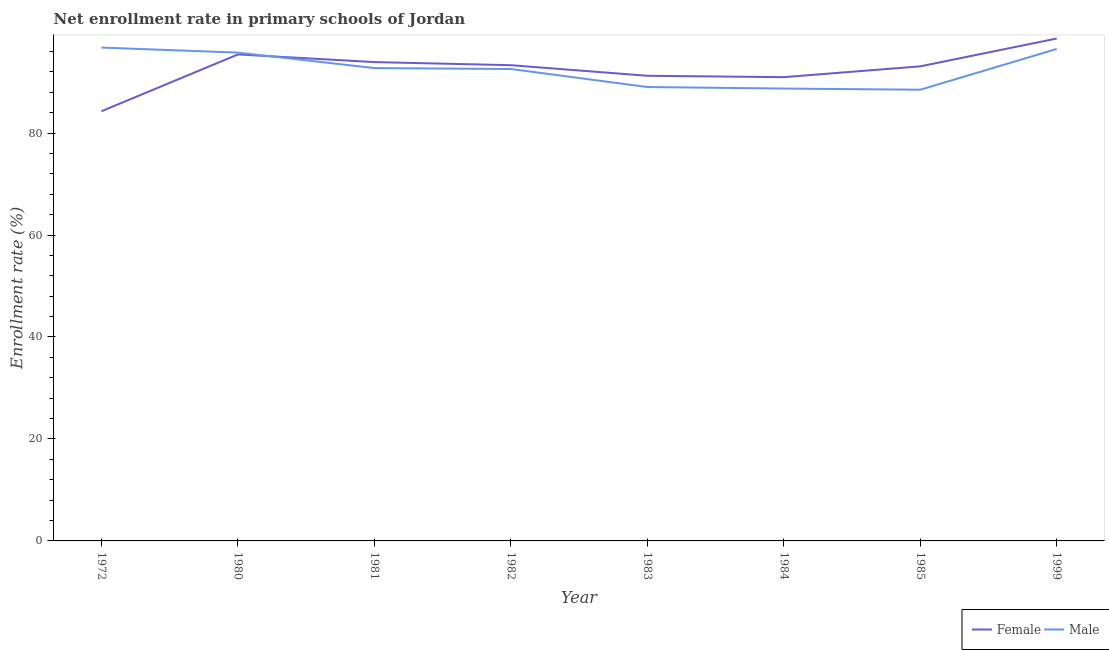How many different coloured lines are there?
Provide a succinct answer. 2. What is the enrollment rate of female students in 1980?
Offer a very short reply. 95.42. Across all years, what is the maximum enrollment rate of male students?
Offer a terse response. 96.76. Across all years, what is the minimum enrollment rate of male students?
Give a very brief answer. 88.5. What is the total enrollment rate of male students in the graph?
Give a very brief answer. 740.58. What is the difference between the enrollment rate of male students in 1972 and that in 1981?
Your answer should be very brief. 4.02. What is the difference between the enrollment rate of male students in 1982 and the enrollment rate of female students in 1983?
Your answer should be compact. 1.33. What is the average enrollment rate of female students per year?
Make the answer very short. 92.59. In the year 1982, what is the difference between the enrollment rate of female students and enrollment rate of male students?
Keep it short and to the point. 0.75. What is the ratio of the enrollment rate of female students in 1982 to that in 1985?
Keep it short and to the point. 1. Is the enrollment rate of male students in 1981 less than that in 1984?
Give a very brief answer. No. What is the difference between the highest and the second highest enrollment rate of female students?
Your answer should be compact. 3.12. What is the difference between the highest and the lowest enrollment rate of female students?
Provide a succinct answer. 14.26. Is the sum of the enrollment rate of female students in 1982 and 1984 greater than the maximum enrollment rate of male students across all years?
Provide a short and direct response. Yes. Does the enrollment rate of female students monotonically increase over the years?
Provide a short and direct response. No. Is the enrollment rate of female students strictly greater than the enrollment rate of male students over the years?
Give a very brief answer. No. How many legend labels are there?
Ensure brevity in your answer.  2. How are the legend labels stacked?
Ensure brevity in your answer.  Horizontal. What is the title of the graph?
Give a very brief answer. Net enrollment rate in primary schools of Jordan. What is the label or title of the Y-axis?
Provide a succinct answer. Enrollment rate (%). What is the Enrollment rate (%) in Female in 1972?
Provide a short and direct response. 84.28. What is the Enrollment rate (%) of Male in 1972?
Keep it short and to the point. 96.76. What is the Enrollment rate (%) of Female in 1980?
Offer a terse response. 95.42. What is the Enrollment rate (%) of Male in 1980?
Your response must be concise. 95.77. What is the Enrollment rate (%) in Female in 1981?
Your answer should be very brief. 93.92. What is the Enrollment rate (%) in Male in 1981?
Make the answer very short. 92.74. What is the Enrollment rate (%) in Female in 1982?
Your answer should be very brief. 93.31. What is the Enrollment rate (%) of Male in 1982?
Your answer should be very brief. 92.56. What is the Enrollment rate (%) of Female in 1983?
Provide a succinct answer. 91.23. What is the Enrollment rate (%) of Male in 1983?
Provide a succinct answer. 89.03. What is the Enrollment rate (%) of Female in 1984?
Provide a short and direct response. 90.96. What is the Enrollment rate (%) of Male in 1984?
Make the answer very short. 88.72. What is the Enrollment rate (%) in Female in 1985?
Your answer should be very brief. 93.08. What is the Enrollment rate (%) in Male in 1985?
Offer a very short reply. 88.5. What is the Enrollment rate (%) of Female in 1999?
Provide a succinct answer. 98.54. What is the Enrollment rate (%) in Male in 1999?
Provide a short and direct response. 96.49. Across all years, what is the maximum Enrollment rate (%) in Female?
Offer a terse response. 98.54. Across all years, what is the maximum Enrollment rate (%) of Male?
Offer a very short reply. 96.76. Across all years, what is the minimum Enrollment rate (%) in Female?
Make the answer very short. 84.28. Across all years, what is the minimum Enrollment rate (%) of Male?
Offer a terse response. 88.5. What is the total Enrollment rate (%) of Female in the graph?
Give a very brief answer. 740.74. What is the total Enrollment rate (%) of Male in the graph?
Your answer should be very brief. 740.58. What is the difference between the Enrollment rate (%) of Female in 1972 and that in 1980?
Your response must be concise. -11.14. What is the difference between the Enrollment rate (%) of Male in 1972 and that in 1980?
Provide a succinct answer. 0.99. What is the difference between the Enrollment rate (%) in Female in 1972 and that in 1981?
Ensure brevity in your answer.  -9.64. What is the difference between the Enrollment rate (%) in Male in 1972 and that in 1981?
Make the answer very short. 4.02. What is the difference between the Enrollment rate (%) in Female in 1972 and that in 1982?
Provide a short and direct response. -9.03. What is the difference between the Enrollment rate (%) in Male in 1972 and that in 1982?
Ensure brevity in your answer.  4.2. What is the difference between the Enrollment rate (%) in Female in 1972 and that in 1983?
Offer a very short reply. -6.95. What is the difference between the Enrollment rate (%) of Male in 1972 and that in 1983?
Your response must be concise. 7.74. What is the difference between the Enrollment rate (%) of Female in 1972 and that in 1984?
Your response must be concise. -6.68. What is the difference between the Enrollment rate (%) of Male in 1972 and that in 1984?
Keep it short and to the point. 8.04. What is the difference between the Enrollment rate (%) of Female in 1972 and that in 1985?
Provide a succinct answer. -8.8. What is the difference between the Enrollment rate (%) in Male in 1972 and that in 1985?
Your response must be concise. 8.27. What is the difference between the Enrollment rate (%) of Female in 1972 and that in 1999?
Provide a short and direct response. -14.26. What is the difference between the Enrollment rate (%) in Male in 1972 and that in 1999?
Give a very brief answer. 0.27. What is the difference between the Enrollment rate (%) in Female in 1980 and that in 1981?
Provide a succinct answer. 1.5. What is the difference between the Enrollment rate (%) in Male in 1980 and that in 1981?
Provide a short and direct response. 3.03. What is the difference between the Enrollment rate (%) of Female in 1980 and that in 1982?
Make the answer very short. 2.11. What is the difference between the Enrollment rate (%) of Male in 1980 and that in 1982?
Your answer should be very brief. 3.22. What is the difference between the Enrollment rate (%) of Female in 1980 and that in 1983?
Keep it short and to the point. 4.19. What is the difference between the Enrollment rate (%) in Male in 1980 and that in 1983?
Ensure brevity in your answer.  6.75. What is the difference between the Enrollment rate (%) in Female in 1980 and that in 1984?
Keep it short and to the point. 4.46. What is the difference between the Enrollment rate (%) in Male in 1980 and that in 1984?
Offer a terse response. 7.05. What is the difference between the Enrollment rate (%) of Female in 1980 and that in 1985?
Offer a very short reply. 2.34. What is the difference between the Enrollment rate (%) in Male in 1980 and that in 1985?
Your answer should be very brief. 7.28. What is the difference between the Enrollment rate (%) of Female in 1980 and that in 1999?
Offer a terse response. -3.12. What is the difference between the Enrollment rate (%) in Male in 1980 and that in 1999?
Make the answer very short. -0.72. What is the difference between the Enrollment rate (%) in Female in 1981 and that in 1982?
Give a very brief answer. 0.61. What is the difference between the Enrollment rate (%) in Male in 1981 and that in 1982?
Ensure brevity in your answer.  0.18. What is the difference between the Enrollment rate (%) of Female in 1981 and that in 1983?
Ensure brevity in your answer.  2.69. What is the difference between the Enrollment rate (%) in Male in 1981 and that in 1983?
Make the answer very short. 3.72. What is the difference between the Enrollment rate (%) of Female in 1981 and that in 1984?
Give a very brief answer. 2.95. What is the difference between the Enrollment rate (%) in Male in 1981 and that in 1984?
Your response must be concise. 4.02. What is the difference between the Enrollment rate (%) in Female in 1981 and that in 1985?
Your answer should be compact. 0.83. What is the difference between the Enrollment rate (%) in Male in 1981 and that in 1985?
Your answer should be compact. 4.25. What is the difference between the Enrollment rate (%) of Female in 1981 and that in 1999?
Provide a short and direct response. -4.63. What is the difference between the Enrollment rate (%) of Male in 1981 and that in 1999?
Your answer should be very brief. -3.75. What is the difference between the Enrollment rate (%) of Female in 1982 and that in 1983?
Your answer should be very brief. 2.08. What is the difference between the Enrollment rate (%) of Male in 1982 and that in 1983?
Your response must be concise. 3.53. What is the difference between the Enrollment rate (%) of Female in 1982 and that in 1984?
Offer a very short reply. 2.35. What is the difference between the Enrollment rate (%) of Male in 1982 and that in 1984?
Keep it short and to the point. 3.83. What is the difference between the Enrollment rate (%) of Female in 1982 and that in 1985?
Offer a very short reply. 0.23. What is the difference between the Enrollment rate (%) in Male in 1982 and that in 1985?
Your response must be concise. 4.06. What is the difference between the Enrollment rate (%) in Female in 1982 and that in 1999?
Ensure brevity in your answer.  -5.23. What is the difference between the Enrollment rate (%) in Male in 1982 and that in 1999?
Provide a short and direct response. -3.94. What is the difference between the Enrollment rate (%) of Female in 1983 and that in 1984?
Provide a succinct answer. 0.27. What is the difference between the Enrollment rate (%) in Male in 1983 and that in 1984?
Your answer should be compact. 0.3. What is the difference between the Enrollment rate (%) of Female in 1983 and that in 1985?
Your answer should be very brief. -1.85. What is the difference between the Enrollment rate (%) of Male in 1983 and that in 1985?
Ensure brevity in your answer.  0.53. What is the difference between the Enrollment rate (%) of Female in 1983 and that in 1999?
Ensure brevity in your answer.  -7.31. What is the difference between the Enrollment rate (%) in Male in 1983 and that in 1999?
Provide a short and direct response. -7.47. What is the difference between the Enrollment rate (%) in Female in 1984 and that in 1985?
Provide a short and direct response. -2.12. What is the difference between the Enrollment rate (%) in Male in 1984 and that in 1985?
Offer a terse response. 0.23. What is the difference between the Enrollment rate (%) of Female in 1984 and that in 1999?
Offer a very short reply. -7.58. What is the difference between the Enrollment rate (%) in Male in 1984 and that in 1999?
Offer a very short reply. -7.77. What is the difference between the Enrollment rate (%) of Female in 1985 and that in 1999?
Your answer should be compact. -5.46. What is the difference between the Enrollment rate (%) in Male in 1985 and that in 1999?
Provide a succinct answer. -8. What is the difference between the Enrollment rate (%) of Female in 1972 and the Enrollment rate (%) of Male in 1980?
Your answer should be compact. -11.5. What is the difference between the Enrollment rate (%) of Female in 1972 and the Enrollment rate (%) of Male in 1981?
Give a very brief answer. -8.46. What is the difference between the Enrollment rate (%) in Female in 1972 and the Enrollment rate (%) in Male in 1982?
Provide a succinct answer. -8.28. What is the difference between the Enrollment rate (%) in Female in 1972 and the Enrollment rate (%) in Male in 1983?
Ensure brevity in your answer.  -4.75. What is the difference between the Enrollment rate (%) in Female in 1972 and the Enrollment rate (%) in Male in 1984?
Make the answer very short. -4.45. What is the difference between the Enrollment rate (%) in Female in 1972 and the Enrollment rate (%) in Male in 1985?
Provide a short and direct response. -4.22. What is the difference between the Enrollment rate (%) of Female in 1972 and the Enrollment rate (%) of Male in 1999?
Your answer should be very brief. -12.22. What is the difference between the Enrollment rate (%) in Female in 1980 and the Enrollment rate (%) in Male in 1981?
Your answer should be very brief. 2.68. What is the difference between the Enrollment rate (%) of Female in 1980 and the Enrollment rate (%) of Male in 1982?
Your answer should be compact. 2.86. What is the difference between the Enrollment rate (%) in Female in 1980 and the Enrollment rate (%) in Male in 1983?
Your response must be concise. 6.39. What is the difference between the Enrollment rate (%) in Female in 1980 and the Enrollment rate (%) in Male in 1984?
Your response must be concise. 6.69. What is the difference between the Enrollment rate (%) in Female in 1980 and the Enrollment rate (%) in Male in 1985?
Make the answer very short. 6.92. What is the difference between the Enrollment rate (%) of Female in 1980 and the Enrollment rate (%) of Male in 1999?
Make the answer very short. -1.08. What is the difference between the Enrollment rate (%) in Female in 1981 and the Enrollment rate (%) in Male in 1982?
Ensure brevity in your answer.  1.36. What is the difference between the Enrollment rate (%) of Female in 1981 and the Enrollment rate (%) of Male in 1983?
Your answer should be very brief. 4.89. What is the difference between the Enrollment rate (%) of Female in 1981 and the Enrollment rate (%) of Male in 1984?
Make the answer very short. 5.19. What is the difference between the Enrollment rate (%) in Female in 1981 and the Enrollment rate (%) in Male in 1985?
Offer a very short reply. 5.42. What is the difference between the Enrollment rate (%) in Female in 1981 and the Enrollment rate (%) in Male in 1999?
Your response must be concise. -2.58. What is the difference between the Enrollment rate (%) in Female in 1982 and the Enrollment rate (%) in Male in 1983?
Provide a succinct answer. 4.28. What is the difference between the Enrollment rate (%) of Female in 1982 and the Enrollment rate (%) of Male in 1984?
Make the answer very short. 4.58. What is the difference between the Enrollment rate (%) in Female in 1982 and the Enrollment rate (%) in Male in 1985?
Your answer should be compact. 4.81. What is the difference between the Enrollment rate (%) of Female in 1982 and the Enrollment rate (%) of Male in 1999?
Offer a very short reply. -3.19. What is the difference between the Enrollment rate (%) in Female in 1983 and the Enrollment rate (%) in Male in 1984?
Give a very brief answer. 2.51. What is the difference between the Enrollment rate (%) of Female in 1983 and the Enrollment rate (%) of Male in 1985?
Offer a very short reply. 2.73. What is the difference between the Enrollment rate (%) in Female in 1983 and the Enrollment rate (%) in Male in 1999?
Your answer should be very brief. -5.26. What is the difference between the Enrollment rate (%) of Female in 1984 and the Enrollment rate (%) of Male in 1985?
Your answer should be very brief. 2.47. What is the difference between the Enrollment rate (%) in Female in 1984 and the Enrollment rate (%) in Male in 1999?
Keep it short and to the point. -5.53. What is the difference between the Enrollment rate (%) of Female in 1985 and the Enrollment rate (%) of Male in 1999?
Ensure brevity in your answer.  -3.41. What is the average Enrollment rate (%) of Female per year?
Provide a succinct answer. 92.59. What is the average Enrollment rate (%) of Male per year?
Your answer should be compact. 92.57. In the year 1972, what is the difference between the Enrollment rate (%) of Female and Enrollment rate (%) of Male?
Your answer should be compact. -12.48. In the year 1980, what is the difference between the Enrollment rate (%) in Female and Enrollment rate (%) in Male?
Provide a succinct answer. -0.36. In the year 1981, what is the difference between the Enrollment rate (%) of Female and Enrollment rate (%) of Male?
Give a very brief answer. 1.17. In the year 1982, what is the difference between the Enrollment rate (%) in Female and Enrollment rate (%) in Male?
Your answer should be very brief. 0.75. In the year 1983, what is the difference between the Enrollment rate (%) in Female and Enrollment rate (%) in Male?
Your response must be concise. 2.2. In the year 1984, what is the difference between the Enrollment rate (%) of Female and Enrollment rate (%) of Male?
Your answer should be very brief. 2.24. In the year 1985, what is the difference between the Enrollment rate (%) of Female and Enrollment rate (%) of Male?
Provide a short and direct response. 4.59. In the year 1999, what is the difference between the Enrollment rate (%) in Female and Enrollment rate (%) in Male?
Make the answer very short. 2.05. What is the ratio of the Enrollment rate (%) of Female in 1972 to that in 1980?
Your answer should be very brief. 0.88. What is the ratio of the Enrollment rate (%) of Male in 1972 to that in 1980?
Offer a terse response. 1.01. What is the ratio of the Enrollment rate (%) in Female in 1972 to that in 1981?
Offer a terse response. 0.9. What is the ratio of the Enrollment rate (%) of Male in 1972 to that in 1981?
Provide a succinct answer. 1.04. What is the ratio of the Enrollment rate (%) of Female in 1972 to that in 1982?
Offer a terse response. 0.9. What is the ratio of the Enrollment rate (%) of Male in 1972 to that in 1982?
Offer a terse response. 1.05. What is the ratio of the Enrollment rate (%) in Female in 1972 to that in 1983?
Ensure brevity in your answer.  0.92. What is the ratio of the Enrollment rate (%) of Male in 1972 to that in 1983?
Give a very brief answer. 1.09. What is the ratio of the Enrollment rate (%) of Female in 1972 to that in 1984?
Offer a terse response. 0.93. What is the ratio of the Enrollment rate (%) in Male in 1972 to that in 1984?
Provide a succinct answer. 1.09. What is the ratio of the Enrollment rate (%) in Female in 1972 to that in 1985?
Ensure brevity in your answer.  0.91. What is the ratio of the Enrollment rate (%) in Male in 1972 to that in 1985?
Ensure brevity in your answer.  1.09. What is the ratio of the Enrollment rate (%) in Female in 1972 to that in 1999?
Make the answer very short. 0.86. What is the ratio of the Enrollment rate (%) in Male in 1972 to that in 1999?
Offer a very short reply. 1. What is the ratio of the Enrollment rate (%) of Male in 1980 to that in 1981?
Your response must be concise. 1.03. What is the ratio of the Enrollment rate (%) of Female in 1980 to that in 1982?
Give a very brief answer. 1.02. What is the ratio of the Enrollment rate (%) in Male in 1980 to that in 1982?
Offer a very short reply. 1.03. What is the ratio of the Enrollment rate (%) in Female in 1980 to that in 1983?
Provide a short and direct response. 1.05. What is the ratio of the Enrollment rate (%) in Male in 1980 to that in 1983?
Your answer should be very brief. 1.08. What is the ratio of the Enrollment rate (%) in Female in 1980 to that in 1984?
Your answer should be very brief. 1.05. What is the ratio of the Enrollment rate (%) in Male in 1980 to that in 1984?
Give a very brief answer. 1.08. What is the ratio of the Enrollment rate (%) of Female in 1980 to that in 1985?
Ensure brevity in your answer.  1.03. What is the ratio of the Enrollment rate (%) in Male in 1980 to that in 1985?
Provide a short and direct response. 1.08. What is the ratio of the Enrollment rate (%) of Female in 1980 to that in 1999?
Keep it short and to the point. 0.97. What is the ratio of the Enrollment rate (%) in Male in 1980 to that in 1999?
Give a very brief answer. 0.99. What is the ratio of the Enrollment rate (%) of Female in 1981 to that in 1982?
Your response must be concise. 1.01. What is the ratio of the Enrollment rate (%) in Male in 1981 to that in 1982?
Provide a succinct answer. 1. What is the ratio of the Enrollment rate (%) in Female in 1981 to that in 1983?
Your answer should be compact. 1.03. What is the ratio of the Enrollment rate (%) in Male in 1981 to that in 1983?
Ensure brevity in your answer.  1.04. What is the ratio of the Enrollment rate (%) of Female in 1981 to that in 1984?
Your answer should be compact. 1.03. What is the ratio of the Enrollment rate (%) of Male in 1981 to that in 1984?
Offer a terse response. 1.05. What is the ratio of the Enrollment rate (%) of Female in 1981 to that in 1985?
Make the answer very short. 1.01. What is the ratio of the Enrollment rate (%) of Male in 1981 to that in 1985?
Give a very brief answer. 1.05. What is the ratio of the Enrollment rate (%) of Female in 1981 to that in 1999?
Offer a very short reply. 0.95. What is the ratio of the Enrollment rate (%) in Male in 1981 to that in 1999?
Offer a very short reply. 0.96. What is the ratio of the Enrollment rate (%) in Female in 1982 to that in 1983?
Your response must be concise. 1.02. What is the ratio of the Enrollment rate (%) in Male in 1982 to that in 1983?
Provide a short and direct response. 1.04. What is the ratio of the Enrollment rate (%) in Female in 1982 to that in 1984?
Your answer should be very brief. 1.03. What is the ratio of the Enrollment rate (%) in Male in 1982 to that in 1984?
Offer a terse response. 1.04. What is the ratio of the Enrollment rate (%) in Male in 1982 to that in 1985?
Your response must be concise. 1.05. What is the ratio of the Enrollment rate (%) in Female in 1982 to that in 1999?
Your answer should be very brief. 0.95. What is the ratio of the Enrollment rate (%) of Male in 1982 to that in 1999?
Your answer should be very brief. 0.96. What is the ratio of the Enrollment rate (%) in Female in 1983 to that in 1984?
Provide a short and direct response. 1. What is the ratio of the Enrollment rate (%) of Male in 1983 to that in 1984?
Provide a short and direct response. 1. What is the ratio of the Enrollment rate (%) of Female in 1983 to that in 1985?
Offer a very short reply. 0.98. What is the ratio of the Enrollment rate (%) of Male in 1983 to that in 1985?
Make the answer very short. 1.01. What is the ratio of the Enrollment rate (%) in Female in 1983 to that in 1999?
Offer a terse response. 0.93. What is the ratio of the Enrollment rate (%) in Male in 1983 to that in 1999?
Your answer should be compact. 0.92. What is the ratio of the Enrollment rate (%) in Female in 1984 to that in 1985?
Your response must be concise. 0.98. What is the ratio of the Enrollment rate (%) of Male in 1984 to that in 1985?
Offer a terse response. 1. What is the ratio of the Enrollment rate (%) in Male in 1984 to that in 1999?
Ensure brevity in your answer.  0.92. What is the ratio of the Enrollment rate (%) of Female in 1985 to that in 1999?
Provide a succinct answer. 0.94. What is the ratio of the Enrollment rate (%) of Male in 1985 to that in 1999?
Your answer should be compact. 0.92. What is the difference between the highest and the second highest Enrollment rate (%) of Female?
Offer a very short reply. 3.12. What is the difference between the highest and the second highest Enrollment rate (%) of Male?
Offer a terse response. 0.27. What is the difference between the highest and the lowest Enrollment rate (%) of Female?
Provide a short and direct response. 14.26. What is the difference between the highest and the lowest Enrollment rate (%) of Male?
Your response must be concise. 8.27. 